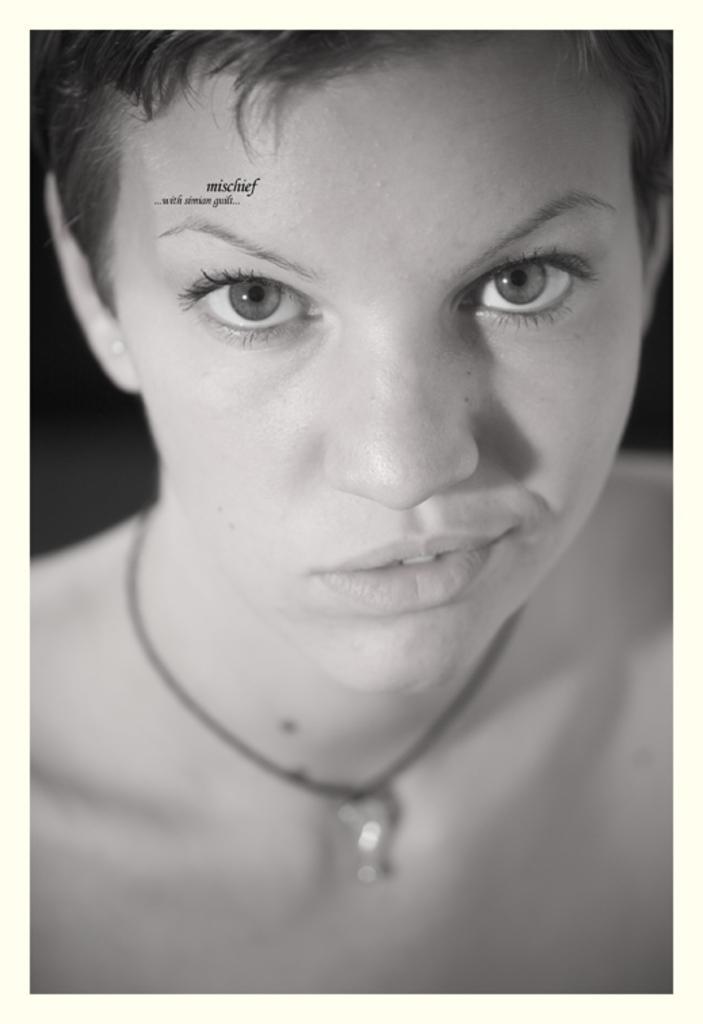Please provide a concise description of this image. In this image I can see a women in the front and I can see she is wearing necklace. On the left side of the forehead I can see something is written and I can also see this image is black and white in colour. 